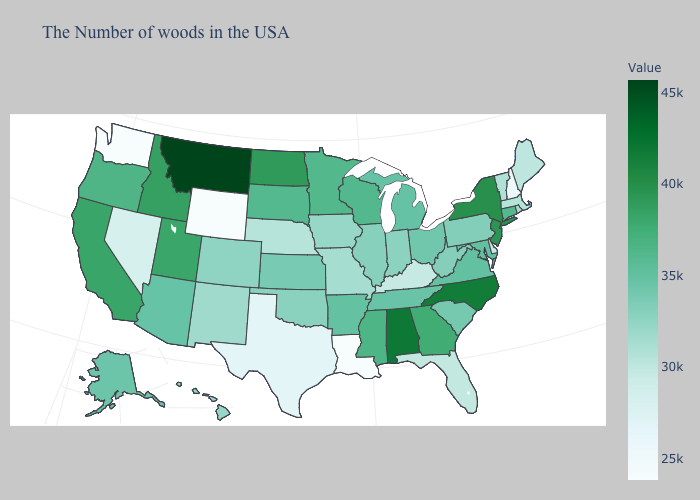Does Alabama have a lower value than Montana?
Short answer required. Yes. Which states hav the highest value in the West?
Be succinct. Montana. Does New Jersey have a higher value than Alabama?
Short answer required. No. Does Kentucky have the lowest value in the USA?
Concise answer only. No. Does New Mexico have a lower value than Mississippi?
Short answer required. Yes. Does the map have missing data?
Be succinct. No. 